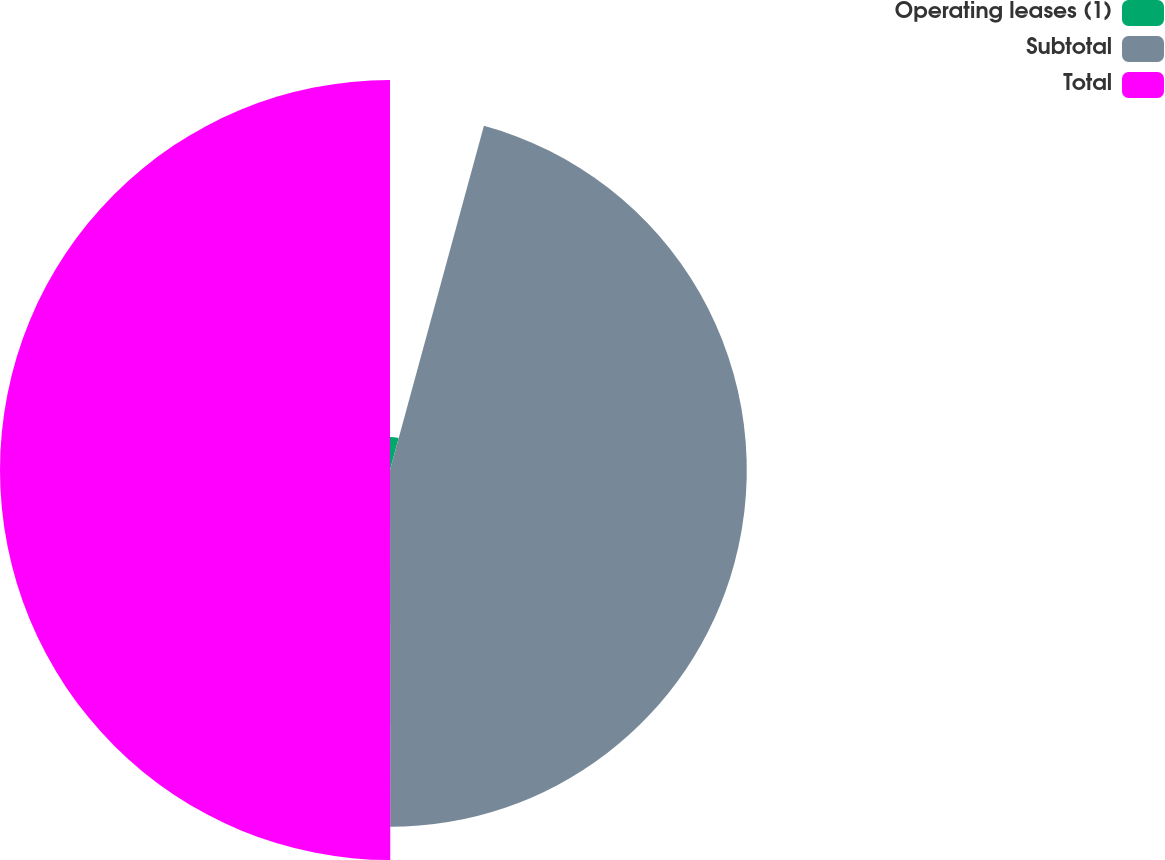Convert chart. <chart><loc_0><loc_0><loc_500><loc_500><pie_chart><fcel>Operating leases (1)<fcel>Subtotal<fcel>Total<nl><fcel>4.24%<fcel>45.75%<fcel>50.01%<nl></chart> 